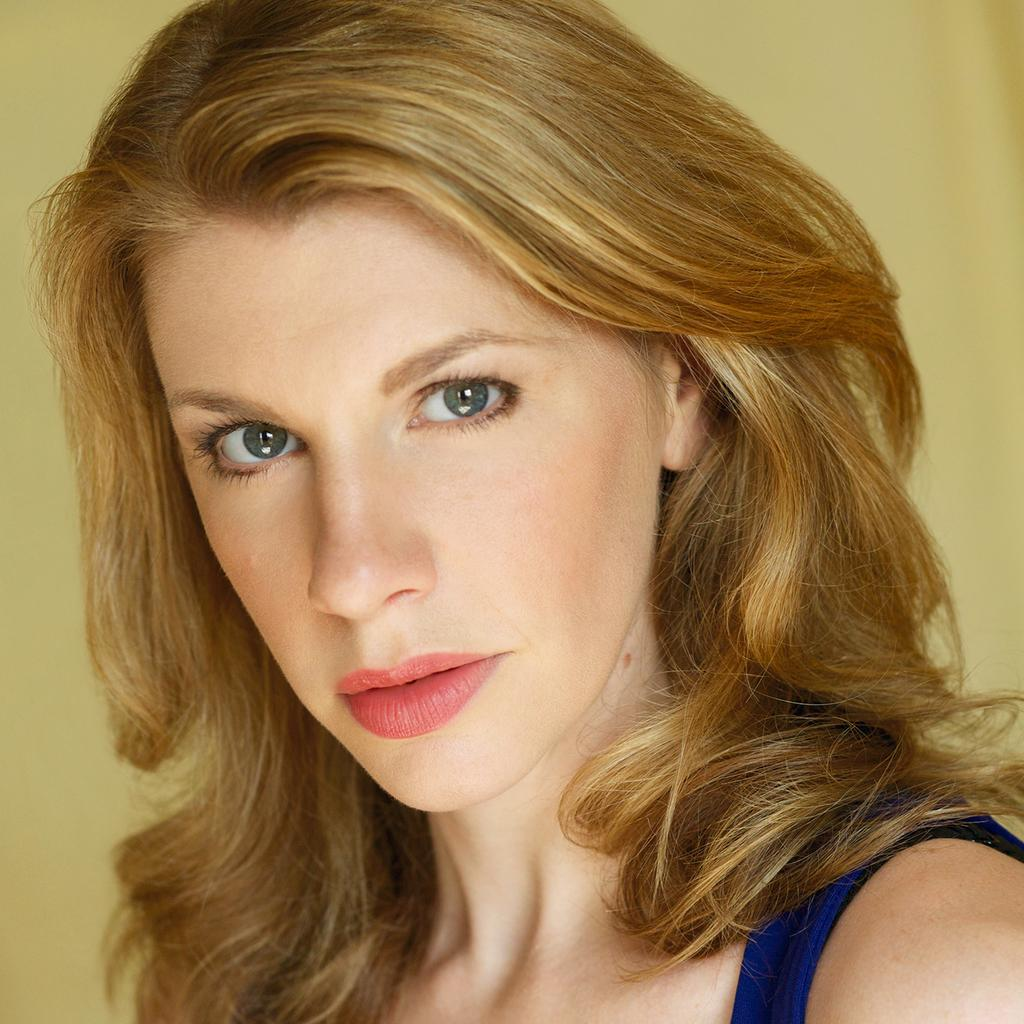What is the main subject in the foreground of the image? There is a woman in the foreground of the image. Can you describe the woman's appearance? The woman has blonde hair. What can be seen in the background of the image? There is a creamy texture in the background of the image. What advice does the woman give to the person in the image? There is no person in the image besides the woman, so it is not possible to determine if she is giving advice to anyone. 